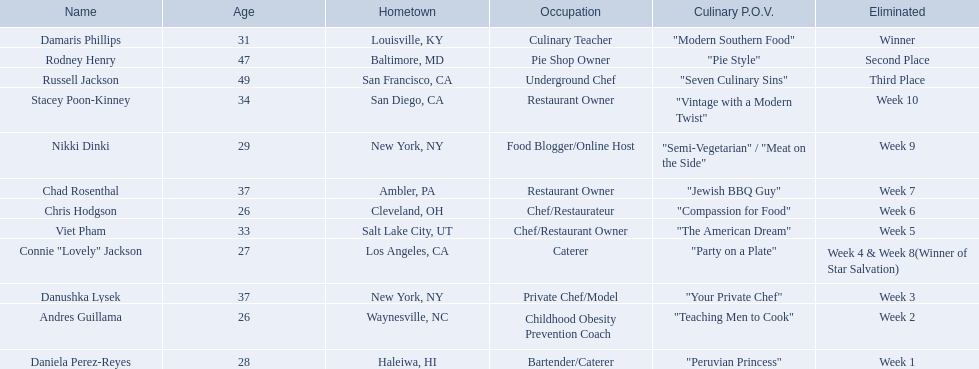Who were the participants in the food network? Damaris Phillips, Rodney Henry, Russell Jackson, Stacey Poon-Kinney, Nikki Dinki, Chad Rosenthal, Chris Hodgson, Viet Pham, Connie "Lovely" Jackson, Danushka Lysek, Andres Guillama, Daniela Perez-Reyes. When was the elimination of nikki dinki? Week 9. When was the elimination of viet pham? Week 5. Which of these two took place earlier? Week 5. Who faced elimination this week? Viet Pham. 